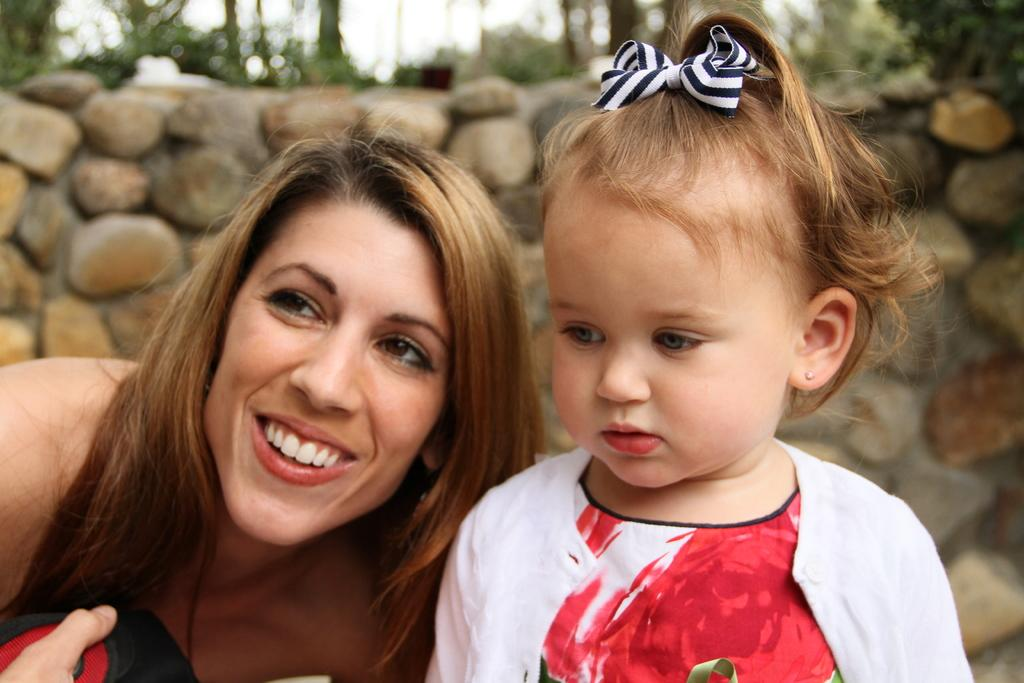Who is present in the image? There is a woman and a child in the image. What can be seen in the background of the image? There is a wall with stones and plants in the background of the image. What is visible in the sky in the image? The sky is visible in the background of the image. What type of fold can be seen in the image? There is no fold present in the image. What cast is performing in the image? There is no cast or performance in the image. 